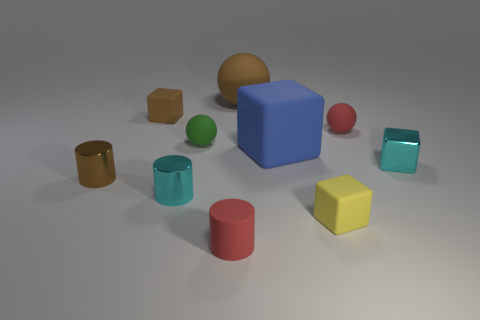There is a cyan object that is the same shape as the small brown rubber object; what material is it?
Make the answer very short. Metal. How many large objects are green matte things or matte cubes?
Your response must be concise. 1. Are there fewer tiny green matte things that are in front of the green object than large spheres that are in front of the tiny shiny cube?
Your response must be concise. No. What number of things are either tiny red things or green metallic cubes?
Offer a terse response. 2. What number of brown metal cylinders are on the right side of the big blue matte block?
Offer a very short reply. 0. What shape is the large brown thing that is made of the same material as the large blue thing?
Offer a very short reply. Sphere. There is a brown matte thing on the right side of the tiny brown matte block; is its shape the same as the green matte object?
Ensure brevity in your answer.  Yes. What number of cyan things are small cylinders or metallic cubes?
Your response must be concise. 2. Are there the same number of shiny cylinders that are behind the big cube and cyan objects to the right of the rubber cylinder?
Offer a terse response. No. The tiny rubber block to the right of the tiny green ball left of the small rubber ball right of the tiny green matte sphere is what color?
Your answer should be very brief. Yellow. 